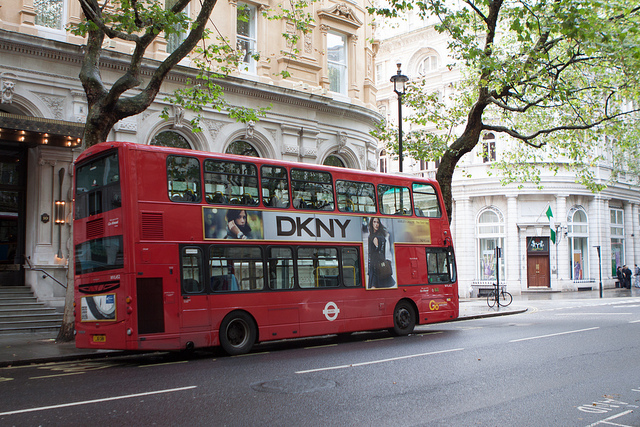<image>Is this America? I am not sure if this is America. However, majority of responses suggest it is not. Is this America? It is not America. 